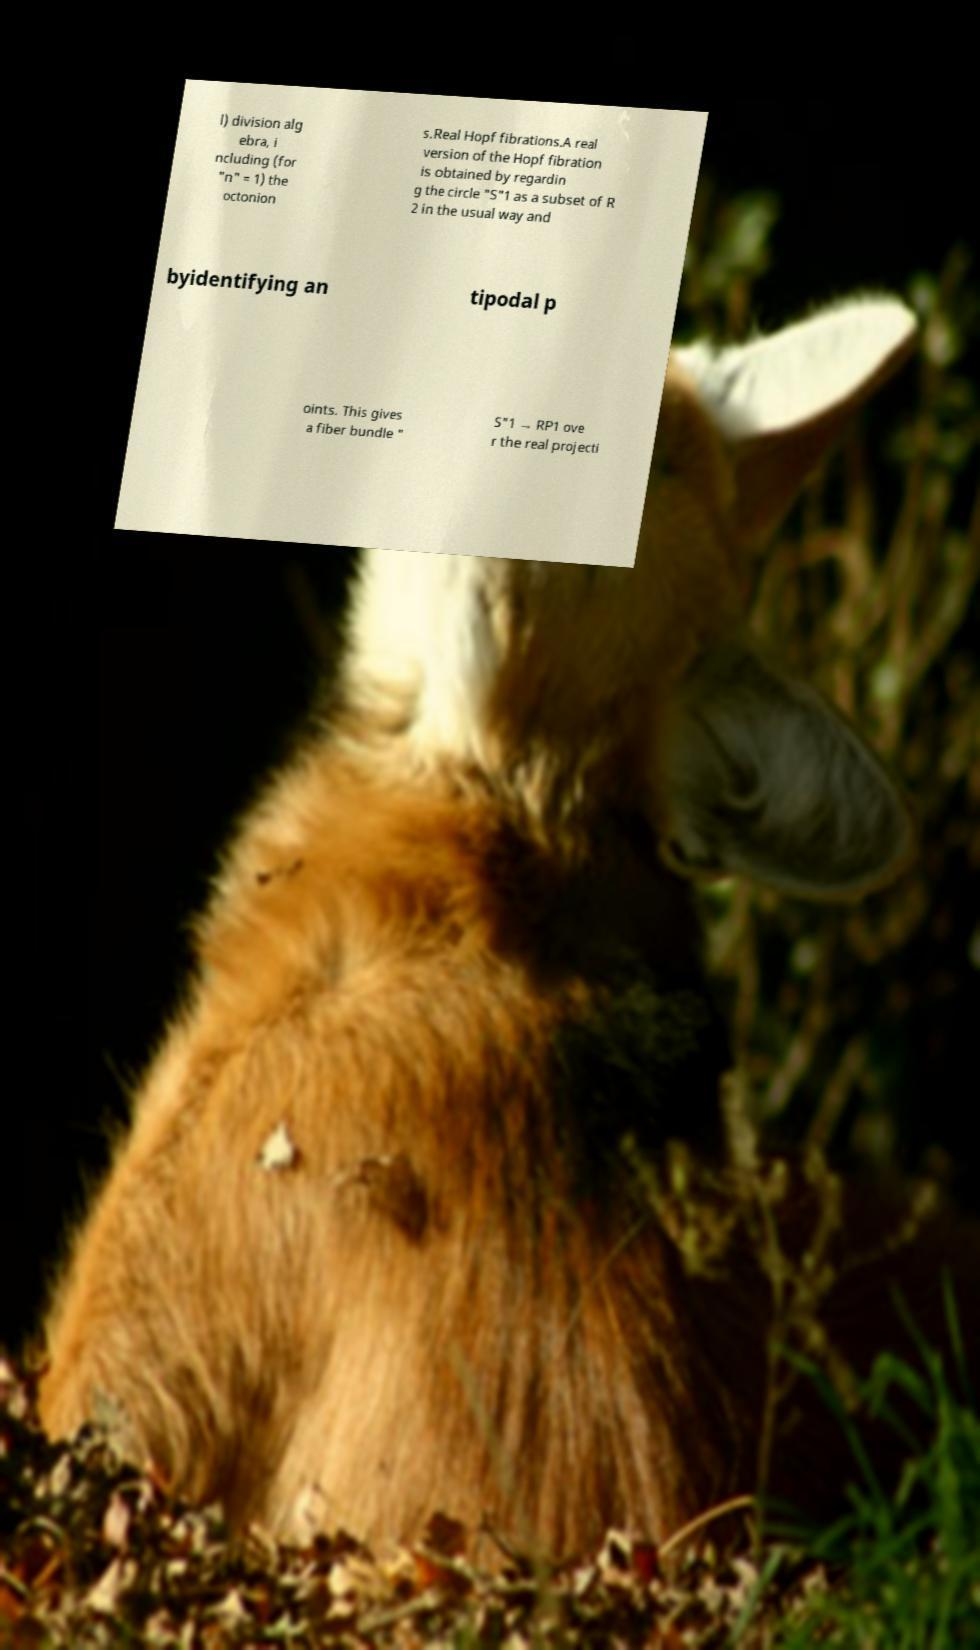Could you assist in decoding the text presented in this image and type it out clearly? l) division alg ebra, i ncluding (for "n" = 1) the octonion s.Real Hopf fibrations.A real version of the Hopf fibration is obtained by regardin g the circle "S"1 as a subset of R 2 in the usual way and byidentifying an tipodal p oints. This gives a fiber bundle " S"1 → RP1 ove r the real projecti 